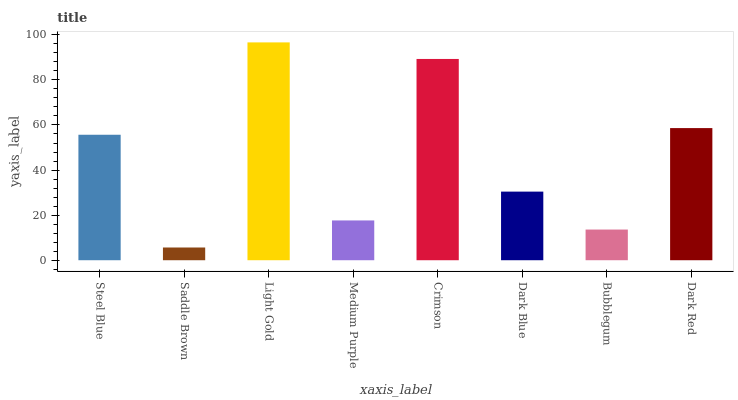Is Light Gold the minimum?
Answer yes or no. No. Is Saddle Brown the maximum?
Answer yes or no. No. Is Light Gold greater than Saddle Brown?
Answer yes or no. Yes. Is Saddle Brown less than Light Gold?
Answer yes or no. Yes. Is Saddle Brown greater than Light Gold?
Answer yes or no. No. Is Light Gold less than Saddle Brown?
Answer yes or no. No. Is Steel Blue the high median?
Answer yes or no. Yes. Is Dark Blue the low median?
Answer yes or no. Yes. Is Crimson the high median?
Answer yes or no. No. Is Light Gold the low median?
Answer yes or no. No. 